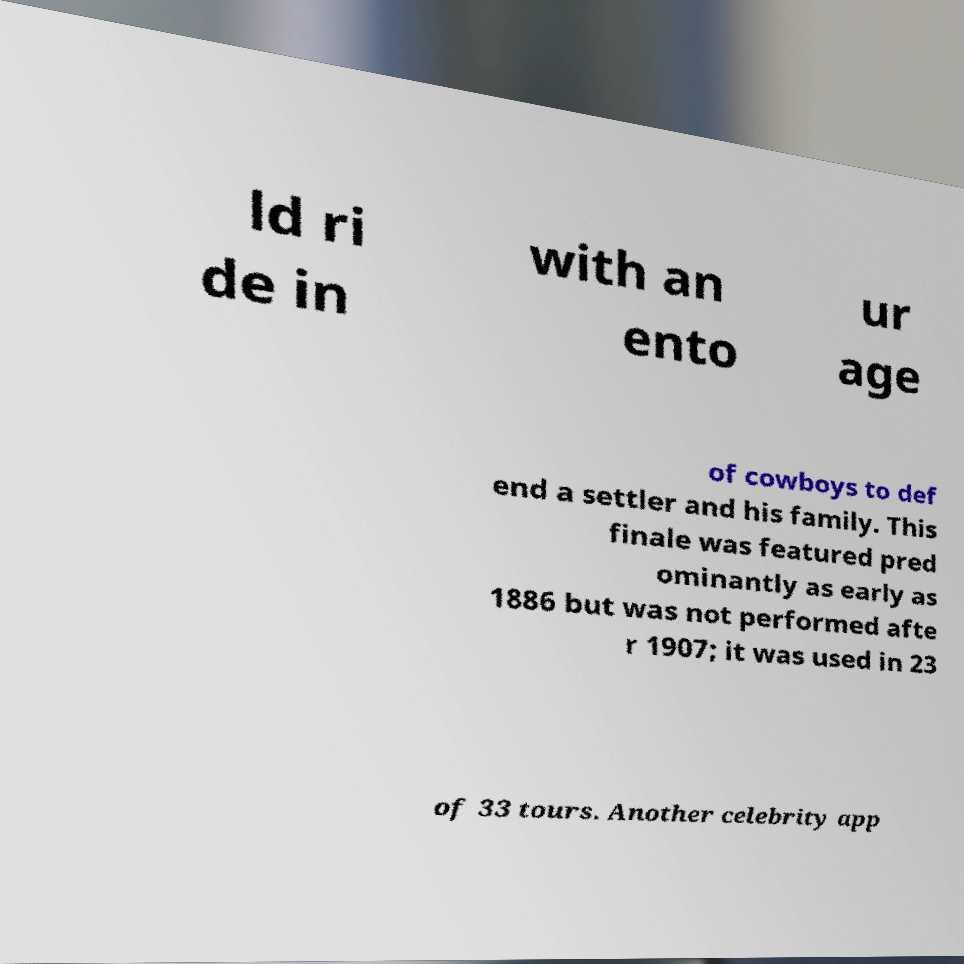Please read and relay the text visible in this image. What does it say? ld ri de in with an ento ur age of cowboys to def end a settler and his family. This finale was featured pred ominantly as early as 1886 but was not performed afte r 1907; it was used in 23 of 33 tours. Another celebrity app 